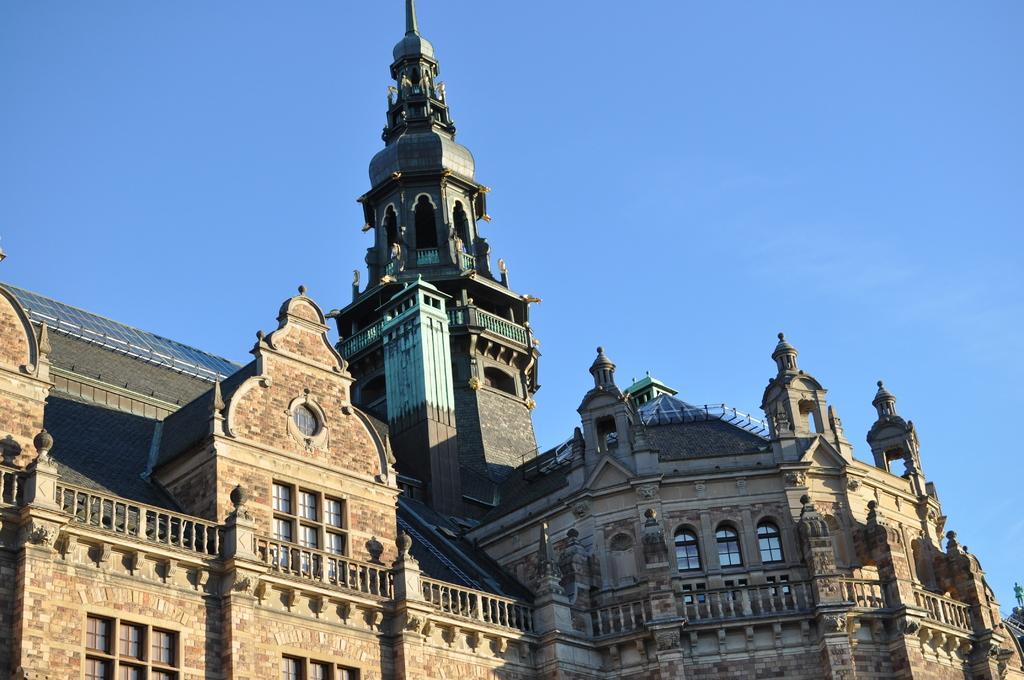In one or two sentences, can you explain what this image depicts? In this image I can see a very big fort with glass windows, at the top it is the sky. 